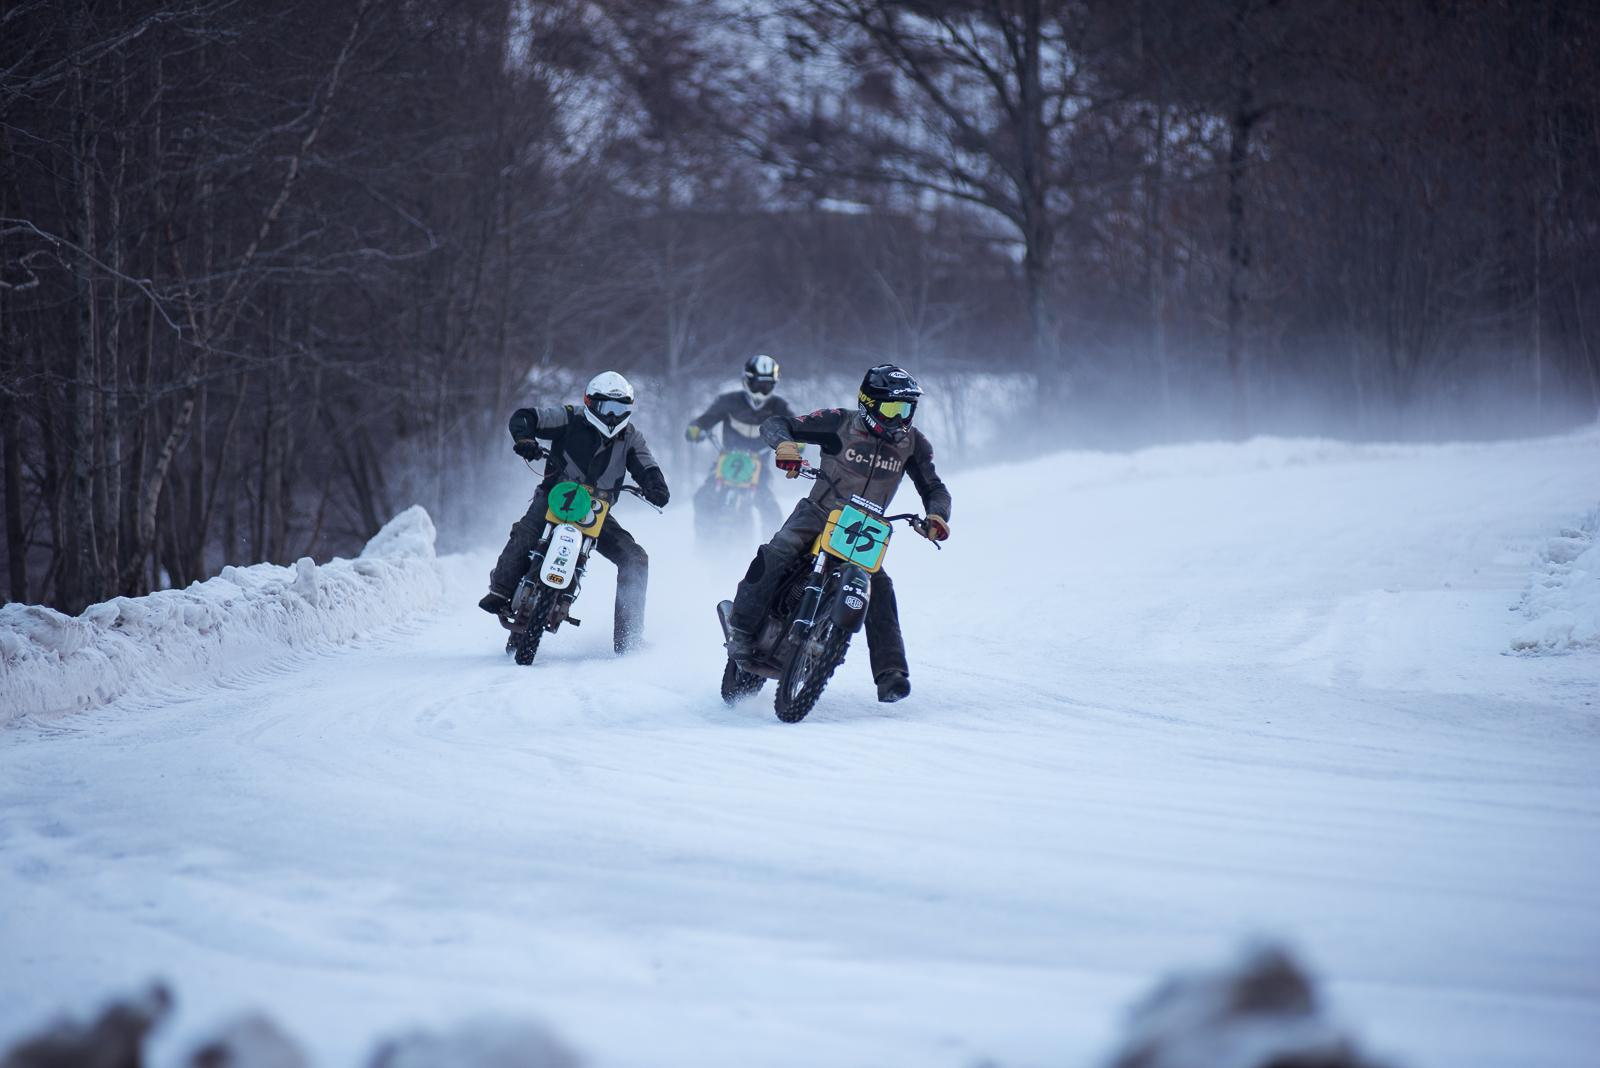What can you say about the gear the riders are wearing? The riders are outfitted with specialized gear that includes helmets, goggles, gloves, and specific cold-weather riding jackets and pants. This gear is essential for both safety and comfort, given the challenges of riding in snowy conditions. 